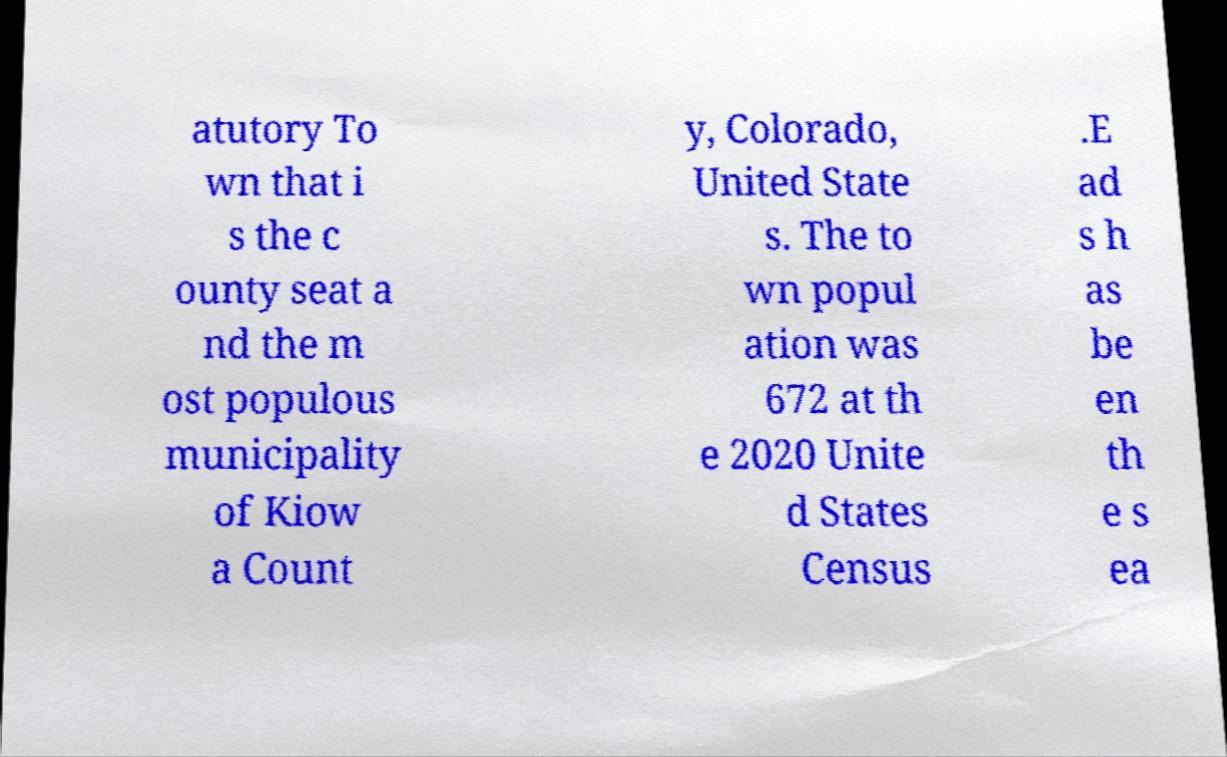Can you accurately transcribe the text from the provided image for me? atutory To wn that i s the c ounty seat a nd the m ost populous municipality of Kiow a Count y, Colorado, United State s. The to wn popul ation was 672 at th e 2020 Unite d States Census .E ad s h as be en th e s ea 